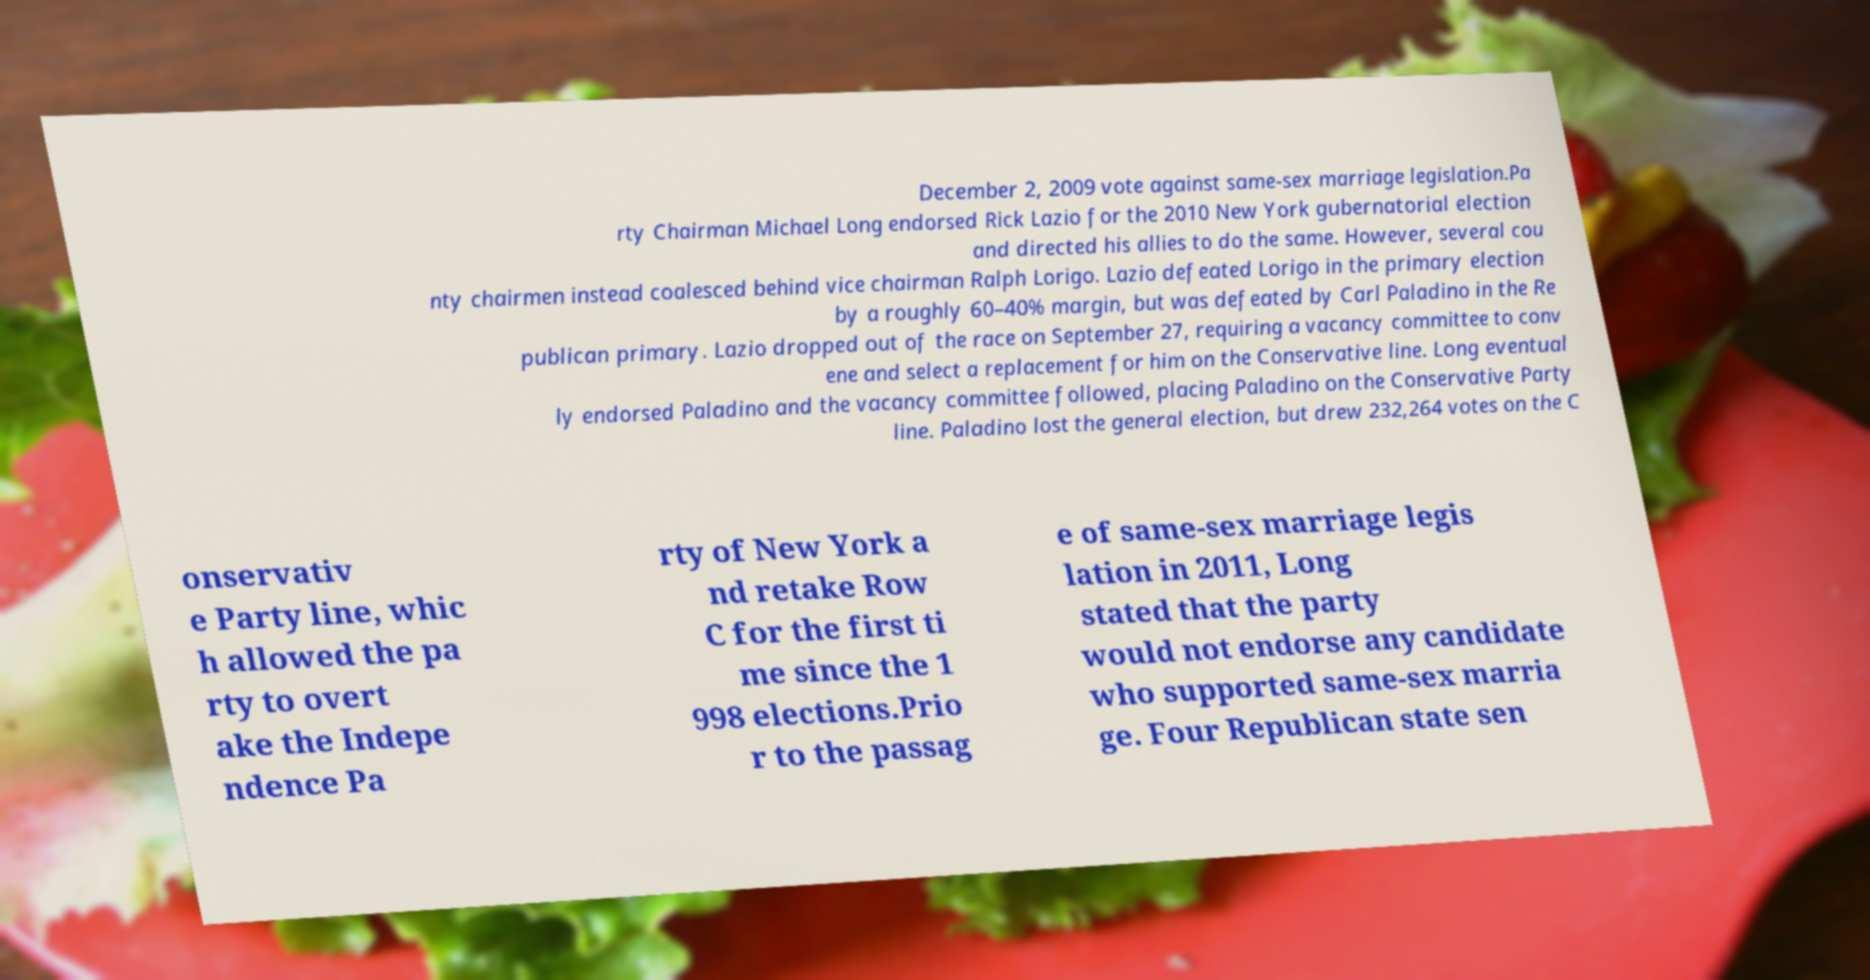There's text embedded in this image that I need extracted. Can you transcribe it verbatim? December 2, 2009 vote against same-sex marriage legislation.Pa rty Chairman Michael Long endorsed Rick Lazio for the 2010 New York gubernatorial election and directed his allies to do the same. However, several cou nty chairmen instead coalesced behind vice chairman Ralph Lorigo. Lazio defeated Lorigo in the primary election by a roughly 60–40% margin, but was defeated by Carl Paladino in the Re publican primary. Lazio dropped out of the race on September 27, requiring a vacancy committee to conv ene and select a replacement for him on the Conservative line. Long eventual ly endorsed Paladino and the vacancy committee followed, placing Paladino on the Conservative Party line. Paladino lost the general election, but drew 232,264 votes on the C onservativ e Party line, whic h allowed the pa rty to overt ake the Indepe ndence Pa rty of New York a nd retake Row C for the first ti me since the 1 998 elections.Prio r to the passag e of same-sex marriage legis lation in 2011, Long stated that the party would not endorse any candidate who supported same-sex marria ge. Four Republican state sen 